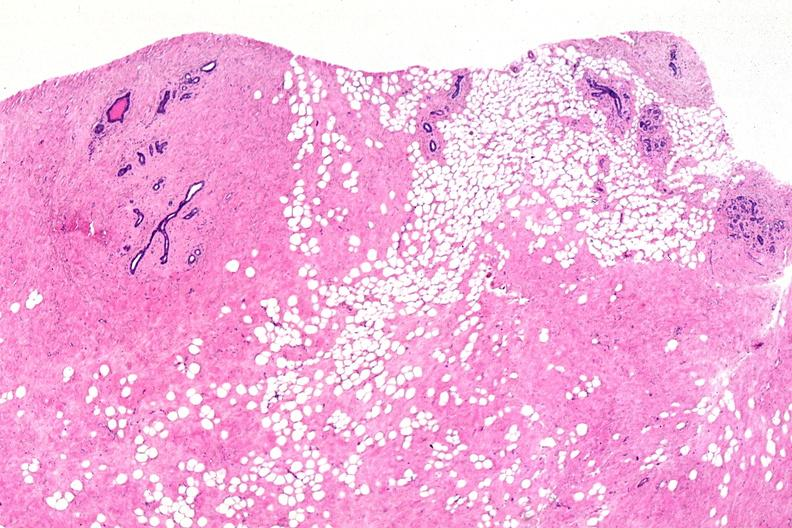s female reproductive present?
Answer the question using a single word or phrase. Yes 